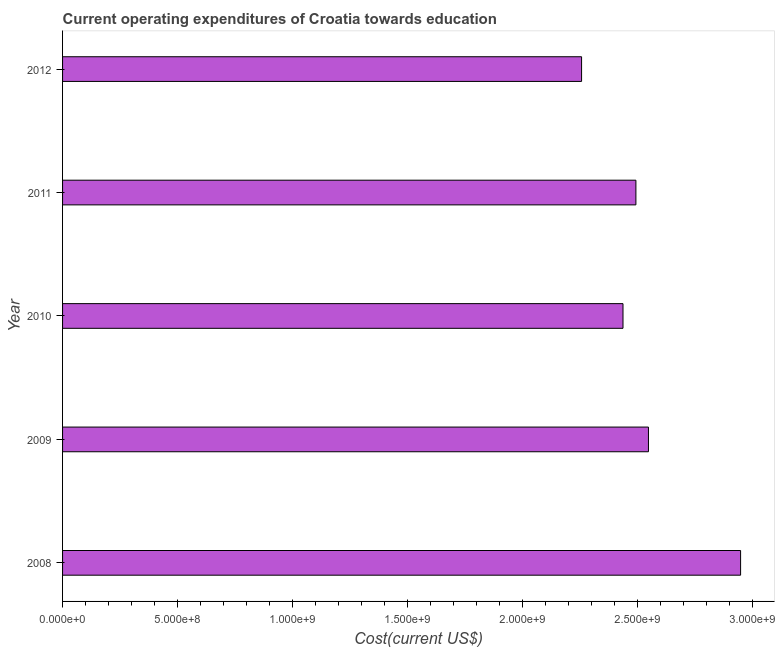Does the graph contain any zero values?
Offer a terse response. No. What is the title of the graph?
Your answer should be very brief. Current operating expenditures of Croatia towards education. What is the label or title of the X-axis?
Your response must be concise. Cost(current US$). What is the label or title of the Y-axis?
Ensure brevity in your answer.  Year. What is the education expenditure in 2010?
Offer a terse response. 2.44e+09. Across all years, what is the maximum education expenditure?
Keep it short and to the point. 2.95e+09. Across all years, what is the minimum education expenditure?
Provide a short and direct response. 2.26e+09. What is the sum of the education expenditure?
Your answer should be compact. 1.27e+1. What is the difference between the education expenditure in 2008 and 2009?
Offer a terse response. 4.00e+08. What is the average education expenditure per year?
Provide a succinct answer. 2.54e+09. What is the median education expenditure?
Provide a succinct answer. 2.49e+09. Is the education expenditure in 2010 less than that in 2012?
Your answer should be very brief. No. Is the difference between the education expenditure in 2008 and 2010 greater than the difference between any two years?
Provide a short and direct response. No. What is the difference between the highest and the second highest education expenditure?
Ensure brevity in your answer.  4.00e+08. What is the difference between the highest and the lowest education expenditure?
Your answer should be very brief. 6.91e+08. Are all the bars in the graph horizontal?
Offer a very short reply. Yes. Are the values on the major ticks of X-axis written in scientific E-notation?
Your response must be concise. Yes. What is the Cost(current US$) of 2008?
Your answer should be compact. 2.95e+09. What is the Cost(current US$) in 2009?
Your response must be concise. 2.55e+09. What is the Cost(current US$) of 2010?
Make the answer very short. 2.44e+09. What is the Cost(current US$) of 2011?
Your answer should be very brief. 2.49e+09. What is the Cost(current US$) of 2012?
Provide a succinct answer. 2.26e+09. What is the difference between the Cost(current US$) in 2008 and 2009?
Keep it short and to the point. 4.00e+08. What is the difference between the Cost(current US$) in 2008 and 2010?
Offer a very short reply. 5.11e+08. What is the difference between the Cost(current US$) in 2008 and 2011?
Your response must be concise. 4.55e+08. What is the difference between the Cost(current US$) in 2008 and 2012?
Provide a succinct answer. 6.91e+08. What is the difference between the Cost(current US$) in 2009 and 2010?
Your answer should be very brief. 1.11e+08. What is the difference between the Cost(current US$) in 2009 and 2011?
Make the answer very short. 5.45e+07. What is the difference between the Cost(current US$) in 2009 and 2012?
Make the answer very short. 2.91e+08. What is the difference between the Cost(current US$) in 2010 and 2011?
Your answer should be compact. -5.61e+07. What is the difference between the Cost(current US$) in 2010 and 2012?
Keep it short and to the point. 1.80e+08. What is the difference between the Cost(current US$) in 2011 and 2012?
Offer a terse response. 2.36e+08. What is the ratio of the Cost(current US$) in 2008 to that in 2009?
Provide a short and direct response. 1.16. What is the ratio of the Cost(current US$) in 2008 to that in 2010?
Give a very brief answer. 1.21. What is the ratio of the Cost(current US$) in 2008 to that in 2011?
Give a very brief answer. 1.18. What is the ratio of the Cost(current US$) in 2008 to that in 2012?
Keep it short and to the point. 1.31. What is the ratio of the Cost(current US$) in 2009 to that in 2010?
Keep it short and to the point. 1.04. What is the ratio of the Cost(current US$) in 2009 to that in 2012?
Offer a very short reply. 1.13. What is the ratio of the Cost(current US$) in 2010 to that in 2011?
Your answer should be very brief. 0.98. What is the ratio of the Cost(current US$) in 2010 to that in 2012?
Your answer should be compact. 1.08. What is the ratio of the Cost(current US$) in 2011 to that in 2012?
Keep it short and to the point. 1.1. 